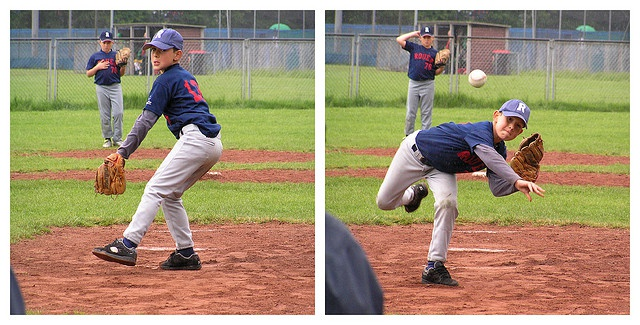Describe the objects in this image and their specific colors. I can see people in white, black, lightgray, darkgray, and gray tones, people in white, lavender, black, darkgray, and navy tones, people in white, gray, and black tones, people in white, darkgray, gray, navy, and black tones, and people in white, darkgray, gray, navy, and black tones in this image. 